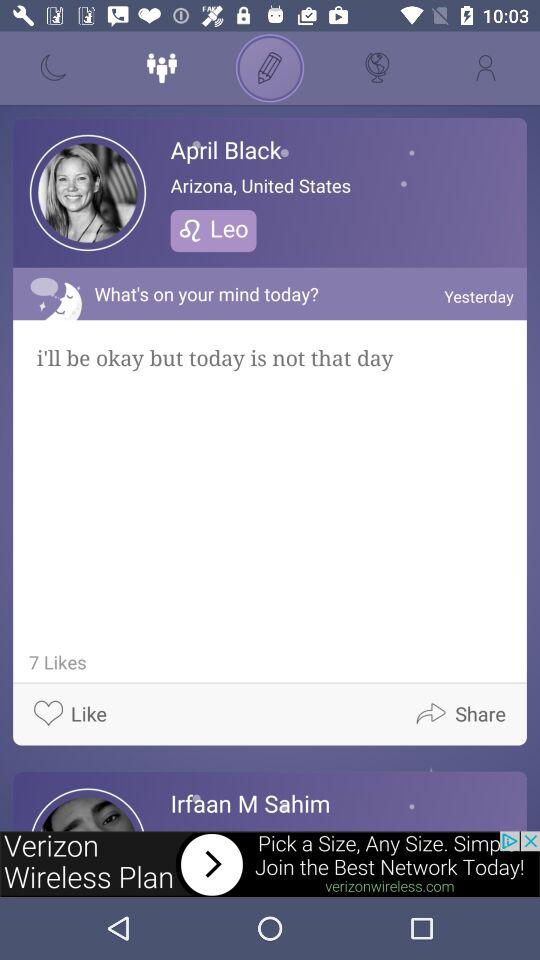From where April Black belongs? April Black belongs to "Arizona, United States". 